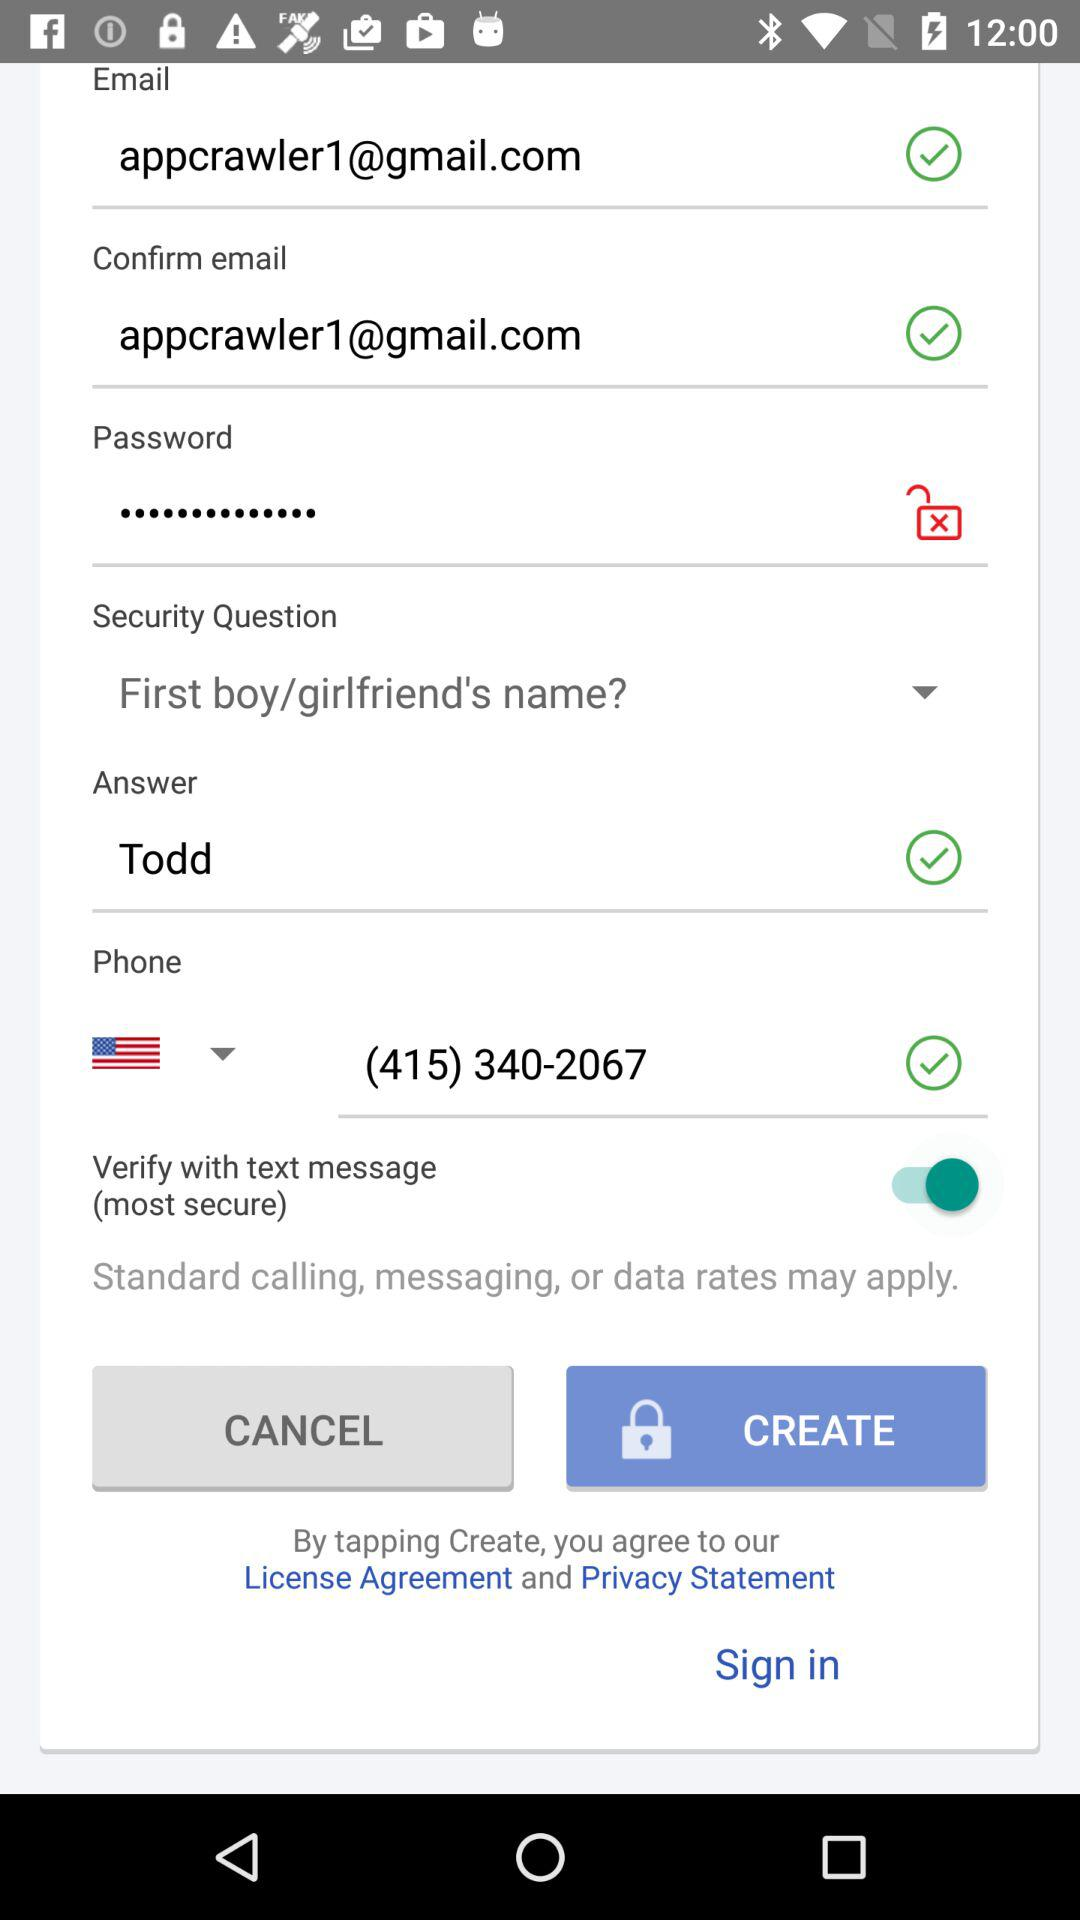How many text input fields are there on this screen?
Answer the question using a single word or phrase. 4 